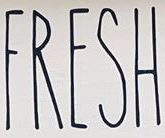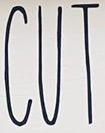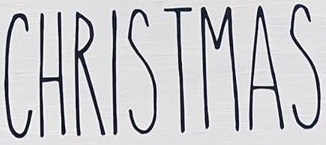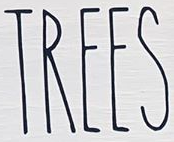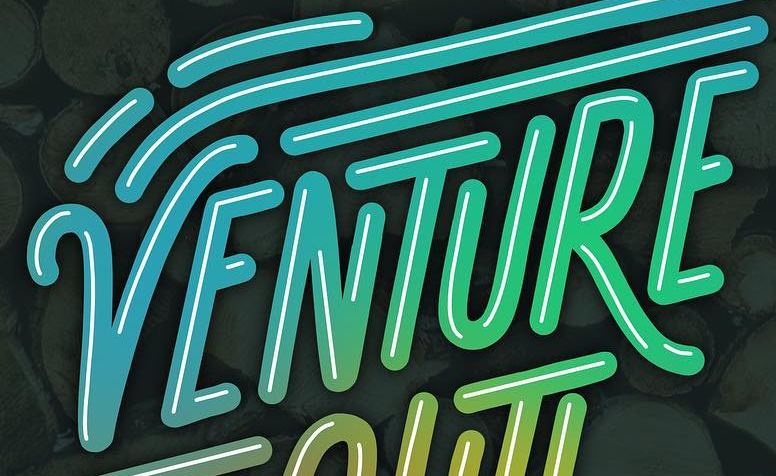Identify the words shown in these images in order, separated by a semicolon. FRESH; CUT; CHRISTMAS; TREES; VENTURE 